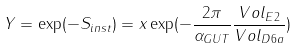<formula> <loc_0><loc_0><loc_500><loc_500>Y = \exp ( - S _ { i n s t } ) = x \exp ( - \frac { 2 \pi } { \alpha _ { G U T } } \frac { V o l _ { E 2 } } { V o l _ { D 6 a } } )</formula> 